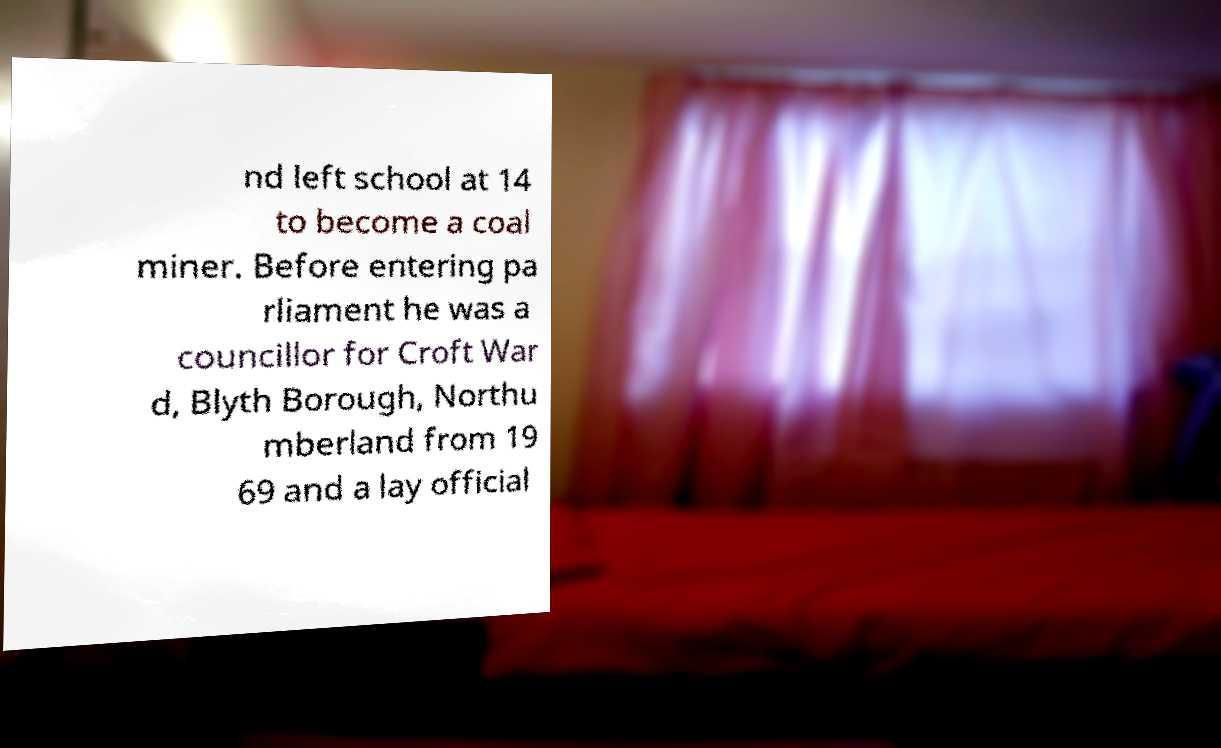Could you extract and type out the text from this image? nd left school at 14 to become a coal miner. Before entering pa rliament he was a councillor for Croft War d, Blyth Borough, Northu mberland from 19 69 and a lay official 